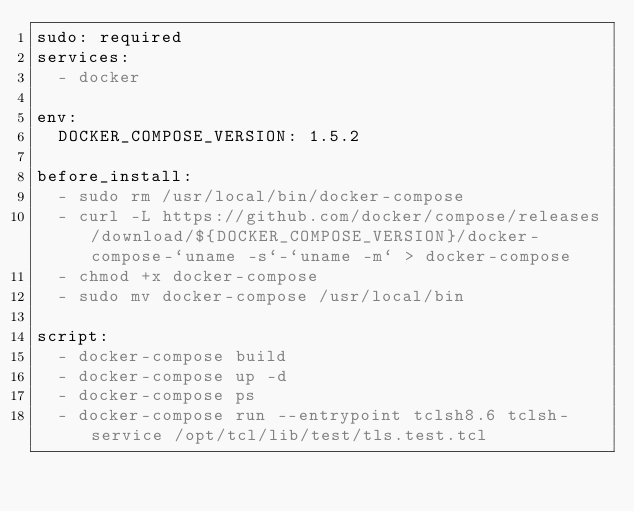<code> <loc_0><loc_0><loc_500><loc_500><_YAML_>sudo: required
services:
  - docker

env:
  DOCKER_COMPOSE_VERSION: 1.5.2

before_install:
  - sudo rm /usr/local/bin/docker-compose
  - curl -L https://github.com/docker/compose/releases/download/${DOCKER_COMPOSE_VERSION}/docker-compose-`uname -s`-`uname -m` > docker-compose
  - chmod +x docker-compose
  - sudo mv docker-compose /usr/local/bin

script:
  - docker-compose build
  - docker-compose up -d
  - docker-compose ps
  - docker-compose run --entrypoint tclsh8.6 tclsh-service /opt/tcl/lib/test/tls.test.tcl
</code> 